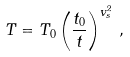<formula> <loc_0><loc_0><loc_500><loc_500>T = T _ { 0 } \left ( \frac { t _ { 0 } } { t } \right ) ^ { v _ { s } ^ { 2 } } \, ,</formula> 